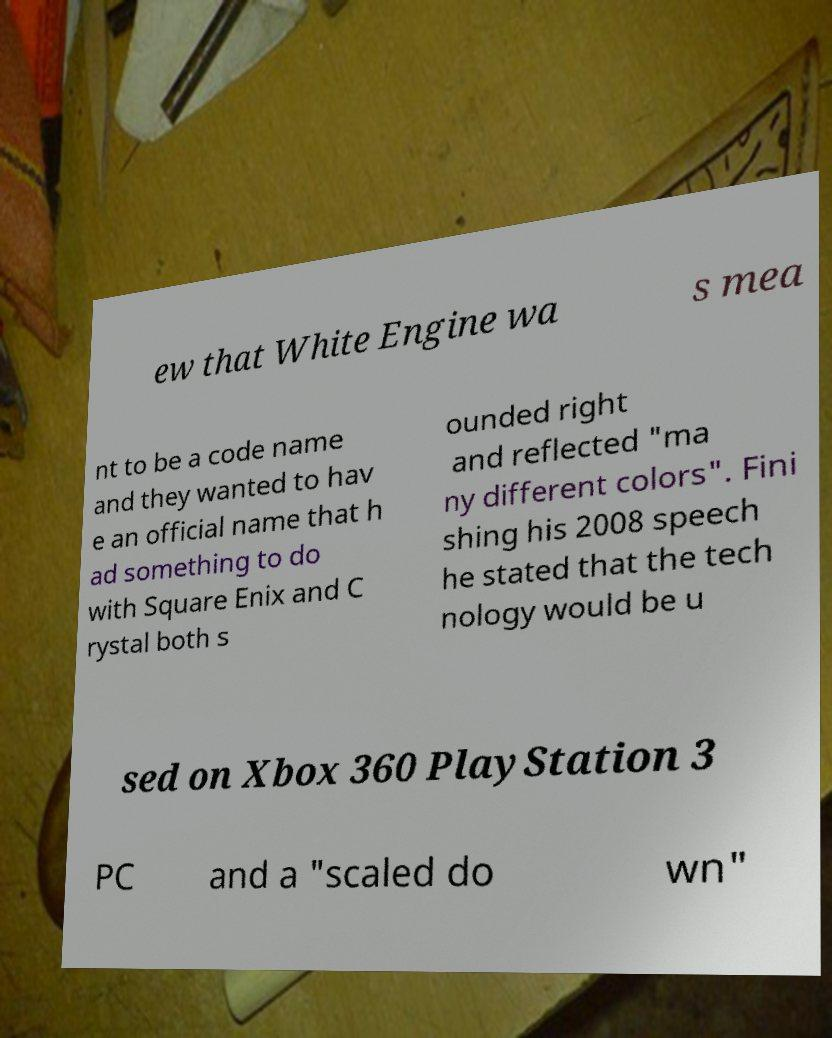Can you accurately transcribe the text from the provided image for me? ew that White Engine wa s mea nt to be a code name and they wanted to hav e an official name that h ad something to do with Square Enix and C rystal both s ounded right and reflected "ma ny different colors". Fini shing his 2008 speech he stated that the tech nology would be u sed on Xbox 360 PlayStation 3 PC and a "scaled do wn" 